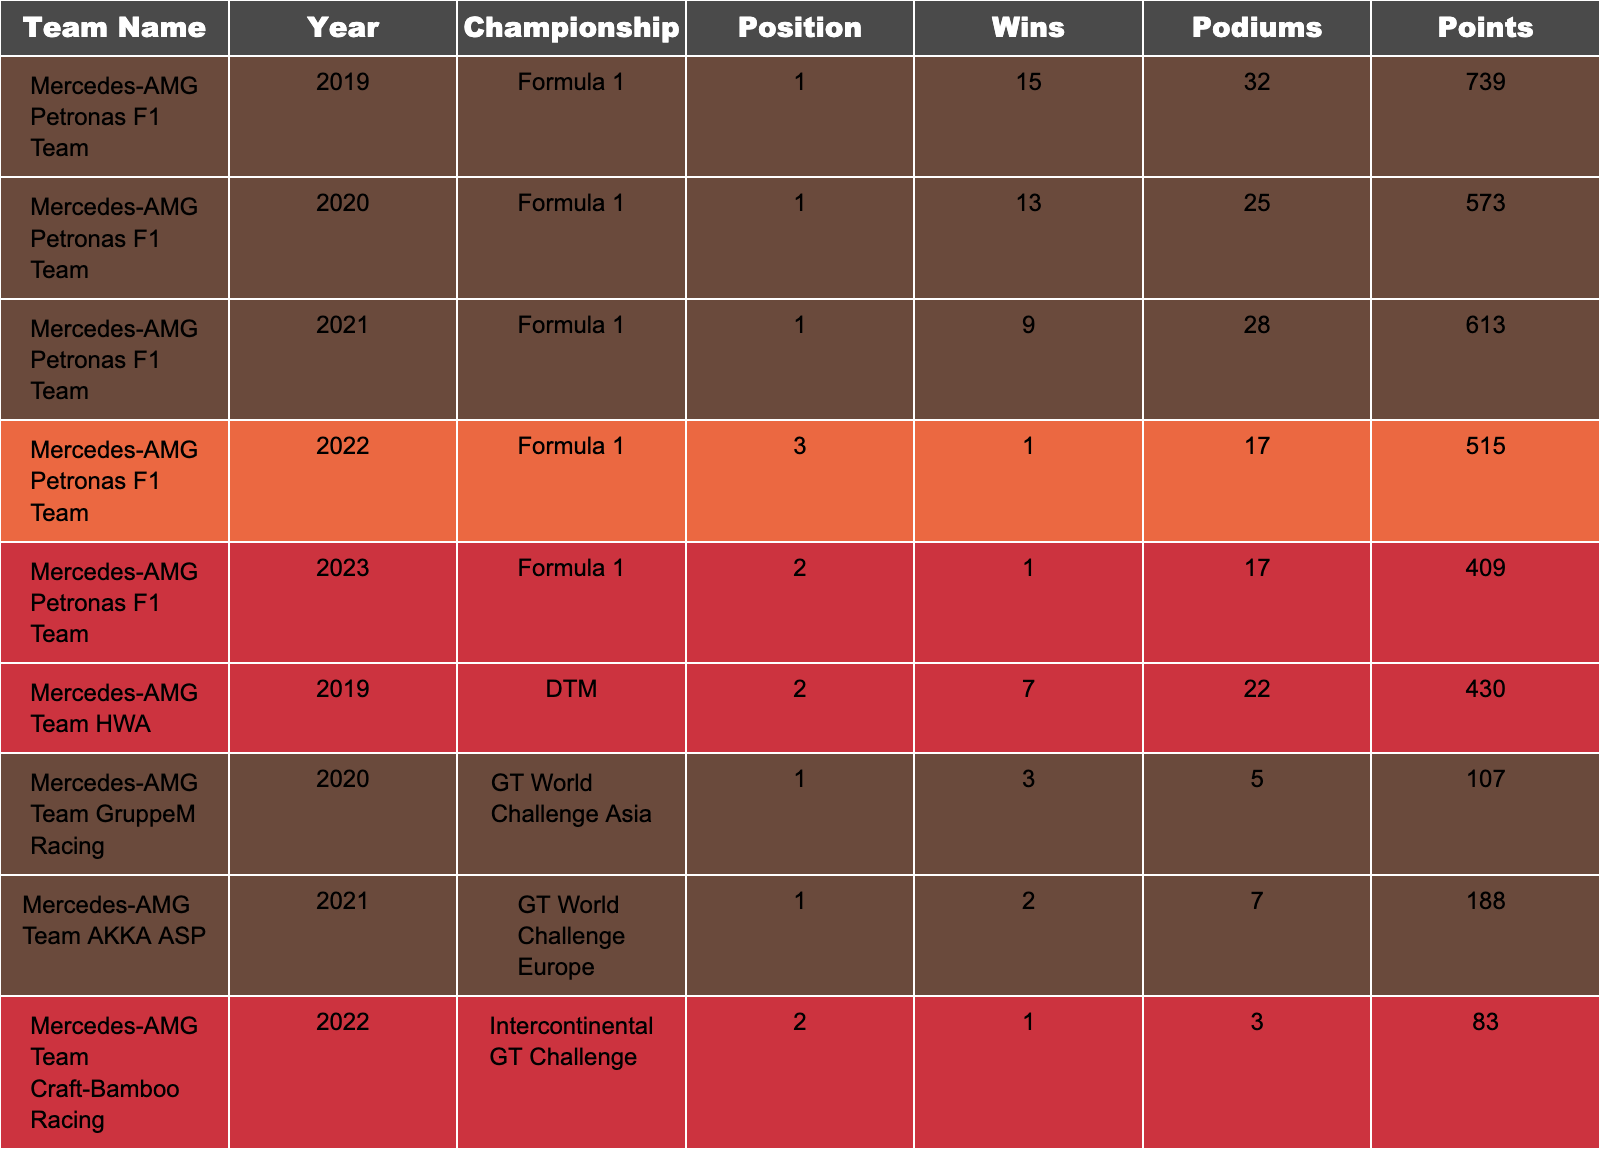What was the highest number of wins achieved by a team in a single year? The table shows that the Mercedes-AMG Petronas F1 Team achieved the highest number of wins, which is 15 in 2019.
Answer: 15 How many podium finishes did the Mercedes-AMG Petronas F1 Team have in 2021? The data indicates the Mercedes-AMG Petronas F1 Team had 28 podium finishes in 2021.
Answer: 28 Which team won the most championships over the 5 years? The Mercedes-AMG Petronas F1 Team consistently secured 1st place from 2019 to 2021, totaling three championships.
Answer: Mercedes-AMG Petronas F1 Team In which year did the Mercedes-AMG Team AKKA ASP achieve the highest position? The table shows that in 2021, the Mercedes-AMG Team AKKA ASP finished in the 1st position in the GT World Challenge Europe.
Answer: 2021 What is the total number of wins across all years for Mercedes-AMG Team HWA? The total wins for Mercedes-AMG Team HWA in the table is the sum of wins in 2019, which is 7. Since there are no other entries in the table, the total is 7.
Answer: 7 Which championship saw the most podium finishes collectively for all teams listed? Analyzing the podium finishes in the table, Formula 1 has the most total podiums, with 32 + 25 + 28 + 17 + 17 = 119 total podiums across five years.
Answer: Formula 1 Did the Mercedes-AMG Team Craft-Bamboo Racing win a championship? The data indicates that the Mercedes-AMG Team Craft-Bamboo Racing finished in 2nd place in the Intercontinental GT Challenge in 2022, which means they did not win the championship that year.
Answer: No What is the average position of the Mercedes-AMG Petronas F1 Team over the five years? The positions for the Mercedes-AMG Petronas F1 Team are 1, 1, 1, 3, and 2. The average position is calculated as (1 + 1 + 1 + 3 + 2) / 5 = 1.6.
Answer: 1.6 How did the performance of the Mercedes-EQ Formula E Team change from 2021 to 2022 in terms of championship position? The Mercedes-EQ Formula E Team finished 1st in both 2021 and 2022, indicating consistent top performance, without any change in championship position.
Answer: No change Which year had the fewest number of wins for the Mercedes-AMG Petronas F1 Team? By examining the data, the Mercedes-AMG Petronas F1 Team recorded only 1 win in 2022, which is the lowest compared to other years.
Answer: 1 win in 2022 What was the total points scored by Mercedes-AMG Team Akkodis ASP in 2023? The table shows that Mercedes-AMG Team Akkodis ASP scored 165 points in 2023, so that is the total points from that year.
Answer: 165 